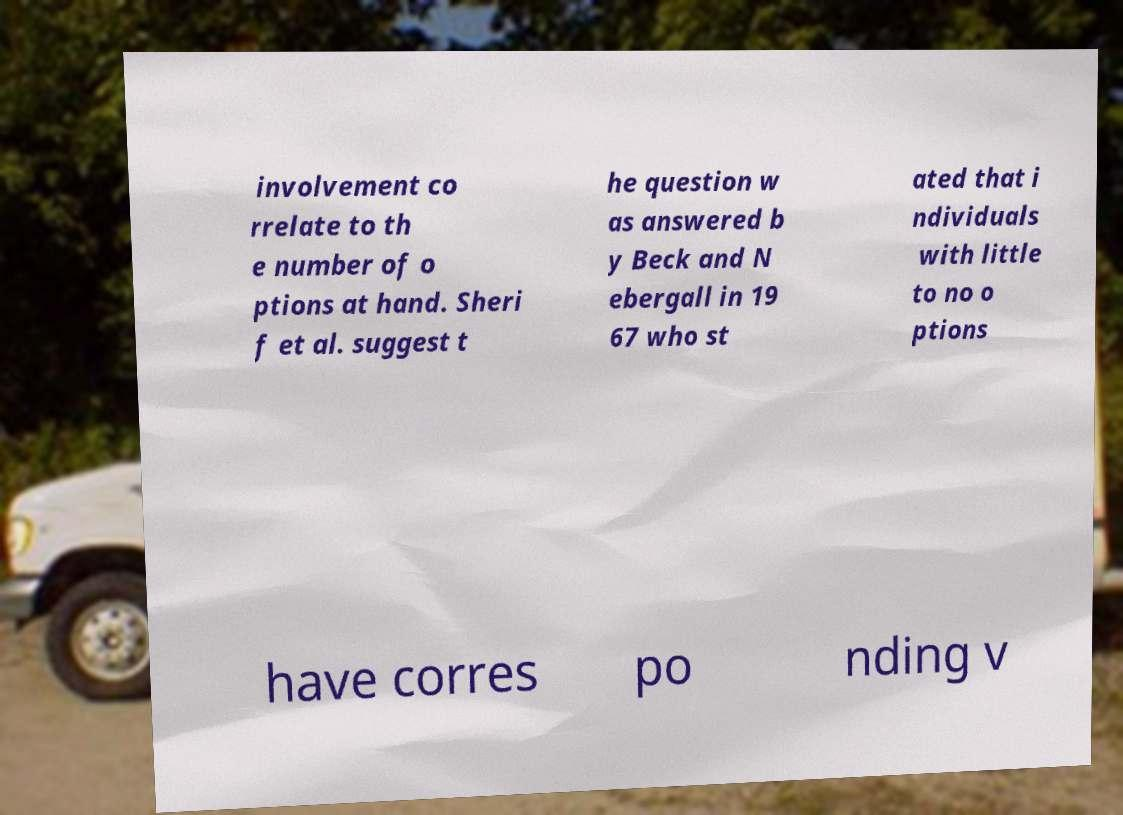What messages or text are displayed in this image? I need them in a readable, typed format. involvement co rrelate to th e number of o ptions at hand. Sheri f et al. suggest t he question w as answered b y Beck and N ebergall in 19 67 who st ated that i ndividuals with little to no o ptions have corres po nding v 